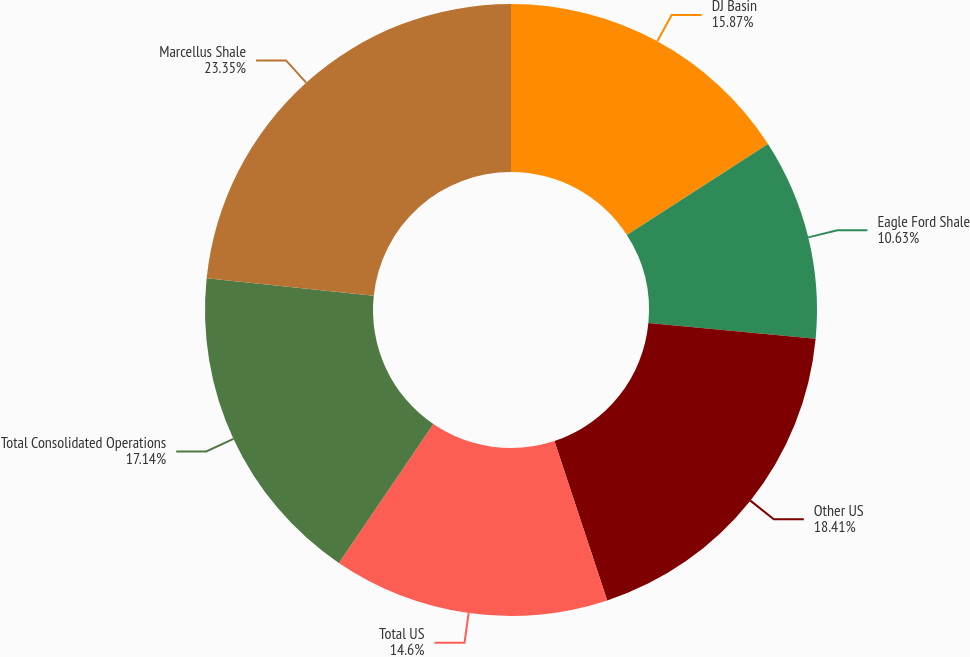<chart> <loc_0><loc_0><loc_500><loc_500><pie_chart><fcel>DJ Basin<fcel>Eagle Ford Shale<fcel>Other US<fcel>Total US<fcel>Total Consolidated Operations<fcel>Marcellus Shale<nl><fcel>15.87%<fcel>10.63%<fcel>18.41%<fcel>14.6%<fcel>17.14%<fcel>23.35%<nl></chart> 